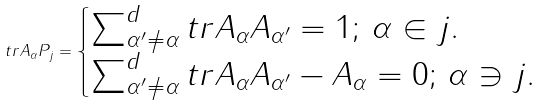Convert formula to latex. <formula><loc_0><loc_0><loc_500><loc_500>t r A _ { \alpha } P _ { j } = \begin{cases} \sum _ { \alpha ^ { \prime } \ne \alpha } ^ { d } t r A _ { \alpha } A _ { \alpha ^ { \prime } } = 1 ; \, \alpha \in j . \\ \sum _ { \alpha ^ { \prime } \ne \alpha } ^ { d } t r A _ { \alpha } A _ { \alpha ^ { \prime } } - A _ { \alpha } = 0 ; \, \alpha \ni j . \end{cases}</formula> 